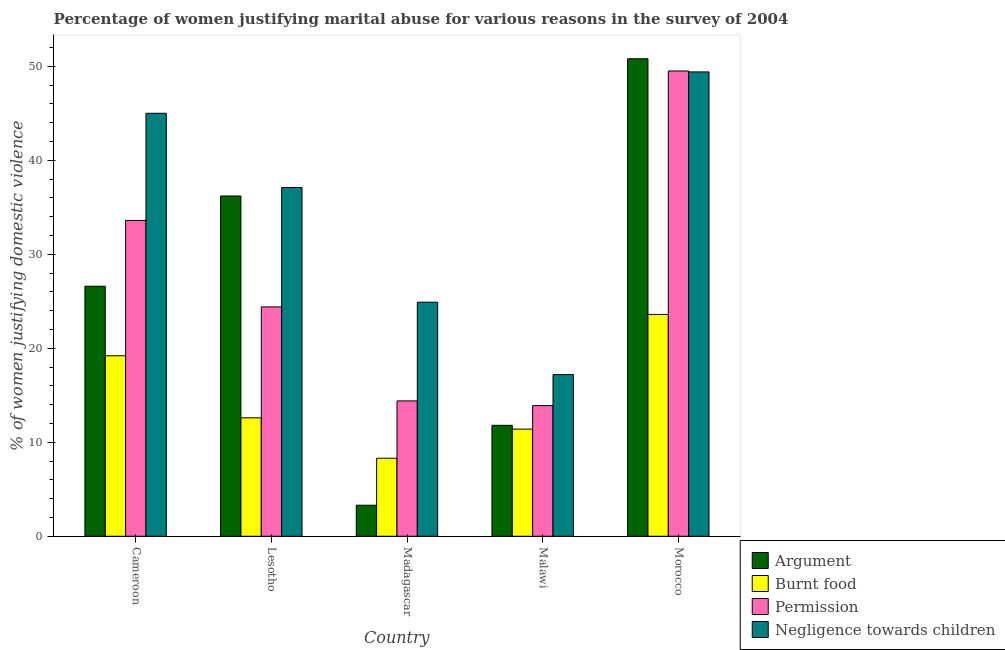Are the number of bars per tick equal to the number of legend labels?
Offer a very short reply. Yes. How many bars are there on the 1st tick from the right?
Provide a succinct answer. 4. What is the label of the 2nd group of bars from the left?
Offer a very short reply. Lesotho. In how many cases, is the number of bars for a given country not equal to the number of legend labels?
Ensure brevity in your answer.  0. What is the percentage of women justifying abuse for showing negligence towards children in Madagascar?
Your answer should be compact. 24.9. Across all countries, what is the maximum percentage of women justifying abuse for going without permission?
Your answer should be compact. 49.5. In which country was the percentage of women justifying abuse for burning food maximum?
Your answer should be compact. Morocco. In which country was the percentage of women justifying abuse for showing negligence towards children minimum?
Your response must be concise. Malawi. What is the total percentage of women justifying abuse in the case of an argument in the graph?
Offer a terse response. 128.7. What is the difference between the percentage of women justifying abuse for going without permission in Cameroon and that in Malawi?
Your response must be concise. 19.7. What is the difference between the percentage of women justifying abuse in the case of an argument in Lesotho and the percentage of women justifying abuse for going without permission in Cameroon?
Provide a succinct answer. 2.6. What is the average percentage of women justifying abuse for going without permission per country?
Keep it short and to the point. 27.16. What is the difference between the percentage of women justifying abuse in the case of an argument and percentage of women justifying abuse for showing negligence towards children in Madagascar?
Ensure brevity in your answer.  -21.6. In how many countries, is the percentage of women justifying abuse for showing negligence towards children greater than 14 %?
Provide a short and direct response. 5. What is the ratio of the percentage of women justifying abuse for showing negligence towards children in Cameroon to that in Madagascar?
Ensure brevity in your answer.  1.81. What is the difference between the highest and the second highest percentage of women justifying abuse in the case of an argument?
Make the answer very short. 14.6. What is the difference between the highest and the lowest percentage of women justifying abuse for burning food?
Your answer should be very brief. 15.3. In how many countries, is the percentage of women justifying abuse for showing negligence towards children greater than the average percentage of women justifying abuse for showing negligence towards children taken over all countries?
Offer a very short reply. 3. Is the sum of the percentage of women justifying abuse for going without permission in Cameroon and Madagascar greater than the maximum percentage of women justifying abuse for burning food across all countries?
Provide a succinct answer. Yes. Is it the case that in every country, the sum of the percentage of women justifying abuse for going without permission and percentage of women justifying abuse for burning food is greater than the sum of percentage of women justifying abuse for showing negligence towards children and percentage of women justifying abuse in the case of an argument?
Your answer should be compact. No. What does the 1st bar from the left in Malawi represents?
Give a very brief answer. Argument. What does the 2nd bar from the right in Cameroon represents?
Provide a succinct answer. Permission. Is it the case that in every country, the sum of the percentage of women justifying abuse in the case of an argument and percentage of women justifying abuse for burning food is greater than the percentage of women justifying abuse for going without permission?
Offer a very short reply. No. How are the legend labels stacked?
Offer a terse response. Vertical. What is the title of the graph?
Offer a very short reply. Percentage of women justifying marital abuse for various reasons in the survey of 2004. Does "Methodology assessment" appear as one of the legend labels in the graph?
Your answer should be compact. No. What is the label or title of the X-axis?
Offer a very short reply. Country. What is the label or title of the Y-axis?
Make the answer very short. % of women justifying domestic violence. What is the % of women justifying domestic violence of Argument in Cameroon?
Your answer should be very brief. 26.6. What is the % of women justifying domestic violence in Burnt food in Cameroon?
Offer a terse response. 19.2. What is the % of women justifying domestic violence in Permission in Cameroon?
Offer a very short reply. 33.6. What is the % of women justifying domestic violence of Argument in Lesotho?
Give a very brief answer. 36.2. What is the % of women justifying domestic violence in Burnt food in Lesotho?
Offer a very short reply. 12.6. What is the % of women justifying domestic violence of Permission in Lesotho?
Offer a very short reply. 24.4. What is the % of women justifying domestic violence of Negligence towards children in Lesotho?
Provide a short and direct response. 37.1. What is the % of women justifying domestic violence in Burnt food in Madagascar?
Provide a succinct answer. 8.3. What is the % of women justifying domestic violence in Permission in Madagascar?
Your response must be concise. 14.4. What is the % of women justifying domestic violence of Negligence towards children in Madagascar?
Make the answer very short. 24.9. What is the % of women justifying domestic violence in Argument in Malawi?
Provide a short and direct response. 11.8. What is the % of women justifying domestic violence in Burnt food in Malawi?
Offer a very short reply. 11.4. What is the % of women justifying domestic violence in Negligence towards children in Malawi?
Provide a succinct answer. 17.2. What is the % of women justifying domestic violence of Argument in Morocco?
Your answer should be very brief. 50.8. What is the % of women justifying domestic violence in Burnt food in Morocco?
Keep it short and to the point. 23.6. What is the % of women justifying domestic violence of Permission in Morocco?
Make the answer very short. 49.5. What is the % of women justifying domestic violence in Negligence towards children in Morocco?
Offer a terse response. 49.4. Across all countries, what is the maximum % of women justifying domestic violence in Argument?
Your answer should be very brief. 50.8. Across all countries, what is the maximum % of women justifying domestic violence of Burnt food?
Ensure brevity in your answer.  23.6. Across all countries, what is the maximum % of women justifying domestic violence in Permission?
Give a very brief answer. 49.5. Across all countries, what is the maximum % of women justifying domestic violence of Negligence towards children?
Your response must be concise. 49.4. Across all countries, what is the minimum % of women justifying domestic violence in Permission?
Offer a very short reply. 13.9. Across all countries, what is the minimum % of women justifying domestic violence of Negligence towards children?
Give a very brief answer. 17.2. What is the total % of women justifying domestic violence in Argument in the graph?
Provide a short and direct response. 128.7. What is the total % of women justifying domestic violence of Burnt food in the graph?
Provide a short and direct response. 75.1. What is the total % of women justifying domestic violence in Permission in the graph?
Keep it short and to the point. 135.8. What is the total % of women justifying domestic violence in Negligence towards children in the graph?
Provide a short and direct response. 173.6. What is the difference between the % of women justifying domestic violence of Permission in Cameroon and that in Lesotho?
Your answer should be very brief. 9.2. What is the difference between the % of women justifying domestic violence of Negligence towards children in Cameroon and that in Lesotho?
Keep it short and to the point. 7.9. What is the difference between the % of women justifying domestic violence in Argument in Cameroon and that in Madagascar?
Provide a succinct answer. 23.3. What is the difference between the % of women justifying domestic violence in Burnt food in Cameroon and that in Madagascar?
Your answer should be very brief. 10.9. What is the difference between the % of women justifying domestic violence of Negligence towards children in Cameroon and that in Madagascar?
Your answer should be very brief. 20.1. What is the difference between the % of women justifying domestic violence of Argument in Cameroon and that in Malawi?
Your answer should be very brief. 14.8. What is the difference between the % of women justifying domestic violence of Burnt food in Cameroon and that in Malawi?
Ensure brevity in your answer.  7.8. What is the difference between the % of women justifying domestic violence in Negligence towards children in Cameroon and that in Malawi?
Your response must be concise. 27.8. What is the difference between the % of women justifying domestic violence in Argument in Cameroon and that in Morocco?
Your response must be concise. -24.2. What is the difference between the % of women justifying domestic violence in Permission in Cameroon and that in Morocco?
Your response must be concise. -15.9. What is the difference between the % of women justifying domestic violence in Negligence towards children in Cameroon and that in Morocco?
Your response must be concise. -4.4. What is the difference between the % of women justifying domestic violence in Argument in Lesotho and that in Madagascar?
Give a very brief answer. 32.9. What is the difference between the % of women justifying domestic violence of Burnt food in Lesotho and that in Madagascar?
Your answer should be compact. 4.3. What is the difference between the % of women justifying domestic violence in Negligence towards children in Lesotho and that in Madagascar?
Give a very brief answer. 12.2. What is the difference between the % of women justifying domestic violence in Argument in Lesotho and that in Malawi?
Provide a short and direct response. 24.4. What is the difference between the % of women justifying domestic violence in Permission in Lesotho and that in Malawi?
Offer a very short reply. 10.5. What is the difference between the % of women justifying domestic violence of Argument in Lesotho and that in Morocco?
Provide a succinct answer. -14.6. What is the difference between the % of women justifying domestic violence in Burnt food in Lesotho and that in Morocco?
Ensure brevity in your answer.  -11. What is the difference between the % of women justifying domestic violence in Permission in Lesotho and that in Morocco?
Make the answer very short. -25.1. What is the difference between the % of women justifying domestic violence in Negligence towards children in Lesotho and that in Morocco?
Offer a very short reply. -12.3. What is the difference between the % of women justifying domestic violence of Argument in Madagascar and that in Malawi?
Provide a short and direct response. -8.5. What is the difference between the % of women justifying domestic violence of Burnt food in Madagascar and that in Malawi?
Make the answer very short. -3.1. What is the difference between the % of women justifying domestic violence of Argument in Madagascar and that in Morocco?
Offer a terse response. -47.5. What is the difference between the % of women justifying domestic violence in Burnt food in Madagascar and that in Morocco?
Give a very brief answer. -15.3. What is the difference between the % of women justifying domestic violence of Permission in Madagascar and that in Morocco?
Offer a very short reply. -35.1. What is the difference between the % of women justifying domestic violence in Negligence towards children in Madagascar and that in Morocco?
Give a very brief answer. -24.5. What is the difference between the % of women justifying domestic violence of Argument in Malawi and that in Morocco?
Keep it short and to the point. -39. What is the difference between the % of women justifying domestic violence in Permission in Malawi and that in Morocco?
Offer a terse response. -35.6. What is the difference between the % of women justifying domestic violence in Negligence towards children in Malawi and that in Morocco?
Give a very brief answer. -32.2. What is the difference between the % of women justifying domestic violence in Argument in Cameroon and the % of women justifying domestic violence in Burnt food in Lesotho?
Ensure brevity in your answer.  14. What is the difference between the % of women justifying domestic violence in Argument in Cameroon and the % of women justifying domestic violence in Permission in Lesotho?
Make the answer very short. 2.2. What is the difference between the % of women justifying domestic violence of Argument in Cameroon and the % of women justifying domestic violence of Negligence towards children in Lesotho?
Give a very brief answer. -10.5. What is the difference between the % of women justifying domestic violence of Burnt food in Cameroon and the % of women justifying domestic violence of Negligence towards children in Lesotho?
Make the answer very short. -17.9. What is the difference between the % of women justifying domestic violence in Argument in Cameroon and the % of women justifying domestic violence in Negligence towards children in Madagascar?
Offer a terse response. 1.7. What is the difference between the % of women justifying domestic violence in Burnt food in Cameroon and the % of women justifying domestic violence in Negligence towards children in Madagascar?
Your response must be concise. -5.7. What is the difference between the % of women justifying domestic violence in Permission in Cameroon and the % of women justifying domestic violence in Negligence towards children in Madagascar?
Offer a very short reply. 8.7. What is the difference between the % of women justifying domestic violence in Argument in Cameroon and the % of women justifying domestic violence in Permission in Malawi?
Your answer should be very brief. 12.7. What is the difference between the % of women justifying domestic violence in Burnt food in Cameroon and the % of women justifying domestic violence in Permission in Malawi?
Give a very brief answer. 5.3. What is the difference between the % of women justifying domestic violence of Permission in Cameroon and the % of women justifying domestic violence of Negligence towards children in Malawi?
Provide a succinct answer. 16.4. What is the difference between the % of women justifying domestic violence in Argument in Cameroon and the % of women justifying domestic violence in Permission in Morocco?
Offer a very short reply. -22.9. What is the difference between the % of women justifying domestic violence of Argument in Cameroon and the % of women justifying domestic violence of Negligence towards children in Morocco?
Your answer should be compact. -22.8. What is the difference between the % of women justifying domestic violence of Burnt food in Cameroon and the % of women justifying domestic violence of Permission in Morocco?
Your answer should be compact. -30.3. What is the difference between the % of women justifying domestic violence in Burnt food in Cameroon and the % of women justifying domestic violence in Negligence towards children in Morocco?
Give a very brief answer. -30.2. What is the difference between the % of women justifying domestic violence in Permission in Cameroon and the % of women justifying domestic violence in Negligence towards children in Morocco?
Provide a short and direct response. -15.8. What is the difference between the % of women justifying domestic violence in Argument in Lesotho and the % of women justifying domestic violence in Burnt food in Madagascar?
Offer a very short reply. 27.9. What is the difference between the % of women justifying domestic violence of Argument in Lesotho and the % of women justifying domestic violence of Permission in Madagascar?
Your answer should be compact. 21.8. What is the difference between the % of women justifying domestic violence in Argument in Lesotho and the % of women justifying domestic violence in Negligence towards children in Madagascar?
Ensure brevity in your answer.  11.3. What is the difference between the % of women justifying domestic violence in Burnt food in Lesotho and the % of women justifying domestic violence in Permission in Madagascar?
Your answer should be compact. -1.8. What is the difference between the % of women justifying domestic violence of Burnt food in Lesotho and the % of women justifying domestic violence of Negligence towards children in Madagascar?
Provide a short and direct response. -12.3. What is the difference between the % of women justifying domestic violence of Permission in Lesotho and the % of women justifying domestic violence of Negligence towards children in Madagascar?
Offer a terse response. -0.5. What is the difference between the % of women justifying domestic violence in Argument in Lesotho and the % of women justifying domestic violence in Burnt food in Malawi?
Offer a very short reply. 24.8. What is the difference between the % of women justifying domestic violence in Argument in Lesotho and the % of women justifying domestic violence in Permission in Malawi?
Offer a terse response. 22.3. What is the difference between the % of women justifying domestic violence in Argument in Lesotho and the % of women justifying domestic violence in Negligence towards children in Malawi?
Keep it short and to the point. 19. What is the difference between the % of women justifying domestic violence of Argument in Lesotho and the % of women justifying domestic violence of Negligence towards children in Morocco?
Offer a very short reply. -13.2. What is the difference between the % of women justifying domestic violence of Burnt food in Lesotho and the % of women justifying domestic violence of Permission in Morocco?
Offer a very short reply. -36.9. What is the difference between the % of women justifying domestic violence of Burnt food in Lesotho and the % of women justifying domestic violence of Negligence towards children in Morocco?
Offer a terse response. -36.8. What is the difference between the % of women justifying domestic violence in Permission in Lesotho and the % of women justifying domestic violence in Negligence towards children in Morocco?
Make the answer very short. -25. What is the difference between the % of women justifying domestic violence in Argument in Madagascar and the % of women justifying domestic violence in Permission in Malawi?
Your answer should be compact. -10.6. What is the difference between the % of women justifying domestic violence of Argument in Madagascar and the % of women justifying domestic violence of Negligence towards children in Malawi?
Provide a short and direct response. -13.9. What is the difference between the % of women justifying domestic violence in Burnt food in Madagascar and the % of women justifying domestic violence in Permission in Malawi?
Ensure brevity in your answer.  -5.6. What is the difference between the % of women justifying domestic violence of Burnt food in Madagascar and the % of women justifying domestic violence of Negligence towards children in Malawi?
Your response must be concise. -8.9. What is the difference between the % of women justifying domestic violence in Argument in Madagascar and the % of women justifying domestic violence in Burnt food in Morocco?
Keep it short and to the point. -20.3. What is the difference between the % of women justifying domestic violence of Argument in Madagascar and the % of women justifying domestic violence of Permission in Morocco?
Make the answer very short. -46.2. What is the difference between the % of women justifying domestic violence of Argument in Madagascar and the % of women justifying domestic violence of Negligence towards children in Morocco?
Make the answer very short. -46.1. What is the difference between the % of women justifying domestic violence in Burnt food in Madagascar and the % of women justifying domestic violence in Permission in Morocco?
Your response must be concise. -41.2. What is the difference between the % of women justifying domestic violence in Burnt food in Madagascar and the % of women justifying domestic violence in Negligence towards children in Morocco?
Offer a terse response. -41.1. What is the difference between the % of women justifying domestic violence of Permission in Madagascar and the % of women justifying domestic violence of Negligence towards children in Morocco?
Make the answer very short. -35. What is the difference between the % of women justifying domestic violence in Argument in Malawi and the % of women justifying domestic violence in Burnt food in Morocco?
Offer a very short reply. -11.8. What is the difference between the % of women justifying domestic violence in Argument in Malawi and the % of women justifying domestic violence in Permission in Morocco?
Offer a very short reply. -37.7. What is the difference between the % of women justifying domestic violence in Argument in Malawi and the % of women justifying domestic violence in Negligence towards children in Morocco?
Your response must be concise. -37.6. What is the difference between the % of women justifying domestic violence in Burnt food in Malawi and the % of women justifying domestic violence in Permission in Morocco?
Offer a terse response. -38.1. What is the difference between the % of women justifying domestic violence in Burnt food in Malawi and the % of women justifying domestic violence in Negligence towards children in Morocco?
Keep it short and to the point. -38. What is the difference between the % of women justifying domestic violence in Permission in Malawi and the % of women justifying domestic violence in Negligence towards children in Morocco?
Provide a short and direct response. -35.5. What is the average % of women justifying domestic violence in Argument per country?
Keep it short and to the point. 25.74. What is the average % of women justifying domestic violence in Burnt food per country?
Offer a very short reply. 15.02. What is the average % of women justifying domestic violence in Permission per country?
Ensure brevity in your answer.  27.16. What is the average % of women justifying domestic violence in Negligence towards children per country?
Keep it short and to the point. 34.72. What is the difference between the % of women justifying domestic violence in Argument and % of women justifying domestic violence in Burnt food in Cameroon?
Your response must be concise. 7.4. What is the difference between the % of women justifying domestic violence of Argument and % of women justifying domestic violence of Negligence towards children in Cameroon?
Your answer should be compact. -18.4. What is the difference between the % of women justifying domestic violence in Burnt food and % of women justifying domestic violence in Permission in Cameroon?
Offer a terse response. -14.4. What is the difference between the % of women justifying domestic violence of Burnt food and % of women justifying domestic violence of Negligence towards children in Cameroon?
Offer a terse response. -25.8. What is the difference between the % of women justifying domestic violence in Permission and % of women justifying domestic violence in Negligence towards children in Cameroon?
Provide a succinct answer. -11.4. What is the difference between the % of women justifying domestic violence of Argument and % of women justifying domestic violence of Burnt food in Lesotho?
Give a very brief answer. 23.6. What is the difference between the % of women justifying domestic violence of Argument and % of women justifying domestic violence of Permission in Lesotho?
Keep it short and to the point. 11.8. What is the difference between the % of women justifying domestic violence in Burnt food and % of women justifying domestic violence in Permission in Lesotho?
Ensure brevity in your answer.  -11.8. What is the difference between the % of women justifying domestic violence of Burnt food and % of women justifying domestic violence of Negligence towards children in Lesotho?
Make the answer very short. -24.5. What is the difference between the % of women justifying domestic violence of Permission and % of women justifying domestic violence of Negligence towards children in Lesotho?
Offer a terse response. -12.7. What is the difference between the % of women justifying domestic violence of Argument and % of women justifying domestic violence of Permission in Madagascar?
Your answer should be compact. -11.1. What is the difference between the % of women justifying domestic violence of Argument and % of women justifying domestic violence of Negligence towards children in Madagascar?
Keep it short and to the point. -21.6. What is the difference between the % of women justifying domestic violence of Burnt food and % of women justifying domestic violence of Permission in Madagascar?
Offer a terse response. -6.1. What is the difference between the % of women justifying domestic violence of Burnt food and % of women justifying domestic violence of Negligence towards children in Madagascar?
Your answer should be very brief. -16.6. What is the difference between the % of women justifying domestic violence in Permission and % of women justifying domestic violence in Negligence towards children in Madagascar?
Make the answer very short. -10.5. What is the difference between the % of women justifying domestic violence in Argument and % of women justifying domestic violence in Permission in Malawi?
Give a very brief answer. -2.1. What is the difference between the % of women justifying domestic violence in Argument and % of women justifying domestic violence in Negligence towards children in Malawi?
Your response must be concise. -5.4. What is the difference between the % of women justifying domestic violence in Burnt food and % of women justifying domestic violence in Permission in Malawi?
Provide a short and direct response. -2.5. What is the difference between the % of women justifying domestic violence of Burnt food and % of women justifying domestic violence of Negligence towards children in Malawi?
Provide a short and direct response. -5.8. What is the difference between the % of women justifying domestic violence of Argument and % of women justifying domestic violence of Burnt food in Morocco?
Provide a short and direct response. 27.2. What is the difference between the % of women justifying domestic violence of Burnt food and % of women justifying domestic violence of Permission in Morocco?
Keep it short and to the point. -25.9. What is the difference between the % of women justifying domestic violence of Burnt food and % of women justifying domestic violence of Negligence towards children in Morocco?
Keep it short and to the point. -25.8. What is the ratio of the % of women justifying domestic violence in Argument in Cameroon to that in Lesotho?
Make the answer very short. 0.73. What is the ratio of the % of women justifying domestic violence in Burnt food in Cameroon to that in Lesotho?
Make the answer very short. 1.52. What is the ratio of the % of women justifying domestic violence in Permission in Cameroon to that in Lesotho?
Your response must be concise. 1.38. What is the ratio of the % of women justifying domestic violence in Negligence towards children in Cameroon to that in Lesotho?
Ensure brevity in your answer.  1.21. What is the ratio of the % of women justifying domestic violence in Argument in Cameroon to that in Madagascar?
Provide a succinct answer. 8.06. What is the ratio of the % of women justifying domestic violence of Burnt food in Cameroon to that in Madagascar?
Give a very brief answer. 2.31. What is the ratio of the % of women justifying domestic violence of Permission in Cameroon to that in Madagascar?
Offer a terse response. 2.33. What is the ratio of the % of women justifying domestic violence in Negligence towards children in Cameroon to that in Madagascar?
Provide a succinct answer. 1.81. What is the ratio of the % of women justifying domestic violence in Argument in Cameroon to that in Malawi?
Make the answer very short. 2.25. What is the ratio of the % of women justifying domestic violence of Burnt food in Cameroon to that in Malawi?
Keep it short and to the point. 1.68. What is the ratio of the % of women justifying domestic violence in Permission in Cameroon to that in Malawi?
Provide a short and direct response. 2.42. What is the ratio of the % of women justifying domestic violence in Negligence towards children in Cameroon to that in Malawi?
Offer a very short reply. 2.62. What is the ratio of the % of women justifying domestic violence of Argument in Cameroon to that in Morocco?
Your answer should be very brief. 0.52. What is the ratio of the % of women justifying domestic violence in Burnt food in Cameroon to that in Morocco?
Offer a very short reply. 0.81. What is the ratio of the % of women justifying domestic violence of Permission in Cameroon to that in Morocco?
Keep it short and to the point. 0.68. What is the ratio of the % of women justifying domestic violence of Negligence towards children in Cameroon to that in Morocco?
Give a very brief answer. 0.91. What is the ratio of the % of women justifying domestic violence in Argument in Lesotho to that in Madagascar?
Offer a very short reply. 10.97. What is the ratio of the % of women justifying domestic violence in Burnt food in Lesotho to that in Madagascar?
Make the answer very short. 1.52. What is the ratio of the % of women justifying domestic violence of Permission in Lesotho to that in Madagascar?
Make the answer very short. 1.69. What is the ratio of the % of women justifying domestic violence of Negligence towards children in Lesotho to that in Madagascar?
Offer a very short reply. 1.49. What is the ratio of the % of women justifying domestic violence in Argument in Lesotho to that in Malawi?
Your answer should be very brief. 3.07. What is the ratio of the % of women justifying domestic violence of Burnt food in Lesotho to that in Malawi?
Provide a succinct answer. 1.11. What is the ratio of the % of women justifying domestic violence of Permission in Lesotho to that in Malawi?
Offer a very short reply. 1.76. What is the ratio of the % of women justifying domestic violence of Negligence towards children in Lesotho to that in Malawi?
Make the answer very short. 2.16. What is the ratio of the % of women justifying domestic violence of Argument in Lesotho to that in Morocco?
Keep it short and to the point. 0.71. What is the ratio of the % of women justifying domestic violence of Burnt food in Lesotho to that in Morocco?
Ensure brevity in your answer.  0.53. What is the ratio of the % of women justifying domestic violence of Permission in Lesotho to that in Morocco?
Your response must be concise. 0.49. What is the ratio of the % of women justifying domestic violence in Negligence towards children in Lesotho to that in Morocco?
Make the answer very short. 0.75. What is the ratio of the % of women justifying domestic violence of Argument in Madagascar to that in Malawi?
Keep it short and to the point. 0.28. What is the ratio of the % of women justifying domestic violence in Burnt food in Madagascar to that in Malawi?
Your answer should be very brief. 0.73. What is the ratio of the % of women justifying domestic violence in Permission in Madagascar to that in Malawi?
Ensure brevity in your answer.  1.04. What is the ratio of the % of women justifying domestic violence of Negligence towards children in Madagascar to that in Malawi?
Ensure brevity in your answer.  1.45. What is the ratio of the % of women justifying domestic violence in Argument in Madagascar to that in Morocco?
Ensure brevity in your answer.  0.07. What is the ratio of the % of women justifying domestic violence of Burnt food in Madagascar to that in Morocco?
Give a very brief answer. 0.35. What is the ratio of the % of women justifying domestic violence in Permission in Madagascar to that in Morocco?
Your response must be concise. 0.29. What is the ratio of the % of women justifying domestic violence of Negligence towards children in Madagascar to that in Morocco?
Provide a short and direct response. 0.5. What is the ratio of the % of women justifying domestic violence of Argument in Malawi to that in Morocco?
Give a very brief answer. 0.23. What is the ratio of the % of women justifying domestic violence in Burnt food in Malawi to that in Morocco?
Offer a very short reply. 0.48. What is the ratio of the % of women justifying domestic violence in Permission in Malawi to that in Morocco?
Give a very brief answer. 0.28. What is the ratio of the % of women justifying domestic violence in Negligence towards children in Malawi to that in Morocco?
Give a very brief answer. 0.35. What is the difference between the highest and the second highest % of women justifying domestic violence of Argument?
Ensure brevity in your answer.  14.6. What is the difference between the highest and the second highest % of women justifying domestic violence in Permission?
Your answer should be very brief. 15.9. What is the difference between the highest and the second highest % of women justifying domestic violence of Negligence towards children?
Your response must be concise. 4.4. What is the difference between the highest and the lowest % of women justifying domestic violence of Argument?
Provide a short and direct response. 47.5. What is the difference between the highest and the lowest % of women justifying domestic violence in Permission?
Keep it short and to the point. 35.6. What is the difference between the highest and the lowest % of women justifying domestic violence of Negligence towards children?
Ensure brevity in your answer.  32.2. 